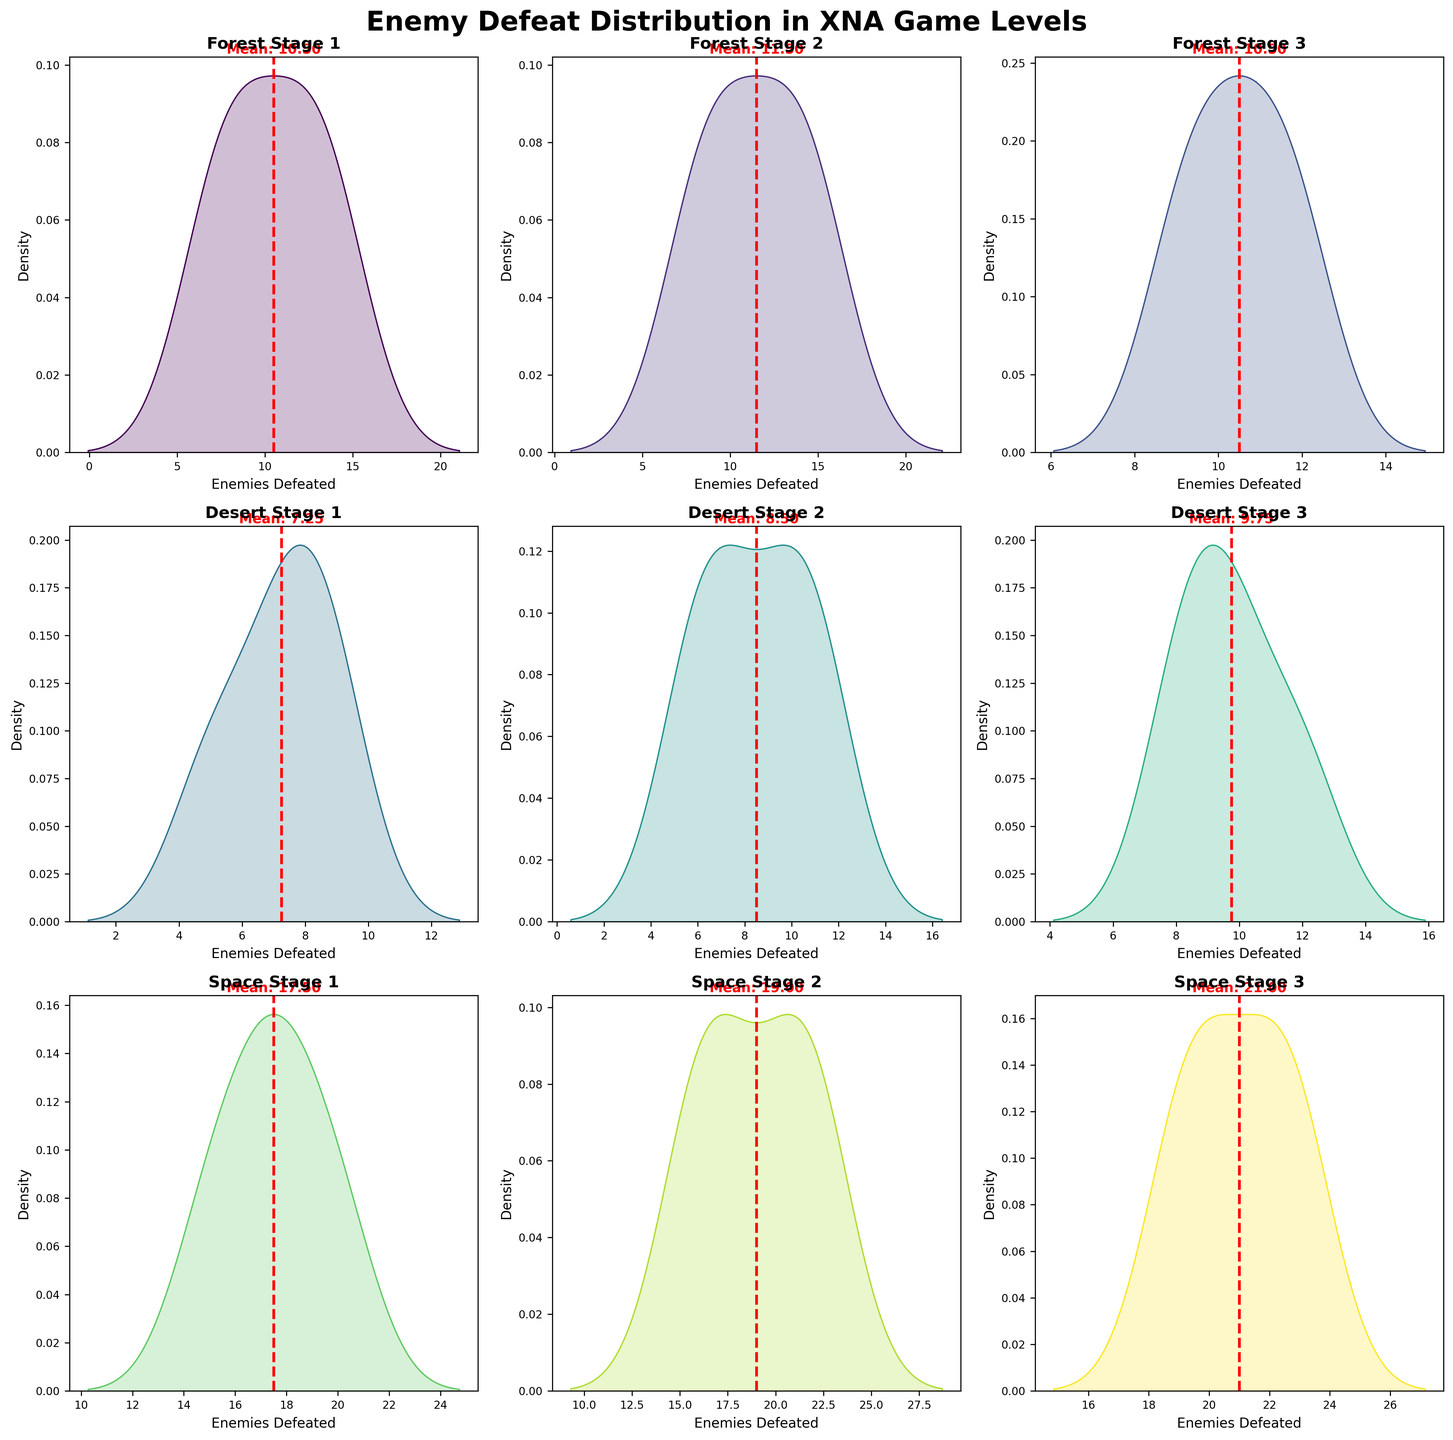Which stage has the highest mean count of enemies defeated? Look at the red dashed lines marking the mean in each subplot. The Space Stage 3 has the highest red dashed line, indicating the highest mean.
Answer: Space Stage 3 How many levels are represented in the figure? Count the number of subplots, each representing a different level in the game. There are 9 subplots, so there are 9 levels.
Answer: 9 Which level in the Forest Stage series has the highest mean count of enemies defeated? Compare the red dashed lines indicating the mean in the three subplots for Forest Stage 1, Forest Stage 2, and Forest Stage 3. Forest Stage 1 has the highest red dashed line among them.
Answer: Forest Stage 1 What is the overall density pattern observed in Desert Stage 1? Observe the shape of the density plot for Desert Stage 1. The density is highest around 7 to 8 enemies defeated and lowers as you move away from these values.
Answer: Highest around 7-8 Do the enemies defeated in Space Stage 2 have a wider range compared to Forest Stage 3? Compare the width of the density plots. The width of a plot is indicated by its spread along the x-axis. Space Stage 2's plot is wider, showing a higher range of enemies defeated.
Answer: Yes What is the mean count of enemies defeated in Desert Stage 2? Look at the red dashed line marking the mean in the Desert Stage 2 subplot. The mean value is indicated by the red text close to this line.
Answer: 8.5 Which stage has the steepest peak in its density plot? Identify the density plot with the sharpest rise and fall. The subplot for Space Stage 1 has a notably steep and high peak.
Answer: Space Stage 1 Which level shows the smallest variance in the number of enemies defeated? Variance is indicated by the spread of the density plot. A narrower plot means smaller variance. Desert Stage 1 shows the smallest variance with a compact distribution.
Answer: Desert Stage 1 Compare the mean count of enemies defeated in Forest Stage 1 and Desert Stage 1. Which is higher? Look at the red dashed lines marking the means in the subplots for Forest Stage 1 and Desert Stage 1. The mean for Forest Stage 1 is higher than that for Desert Stage 1.
Answer: Forest Stage 1 